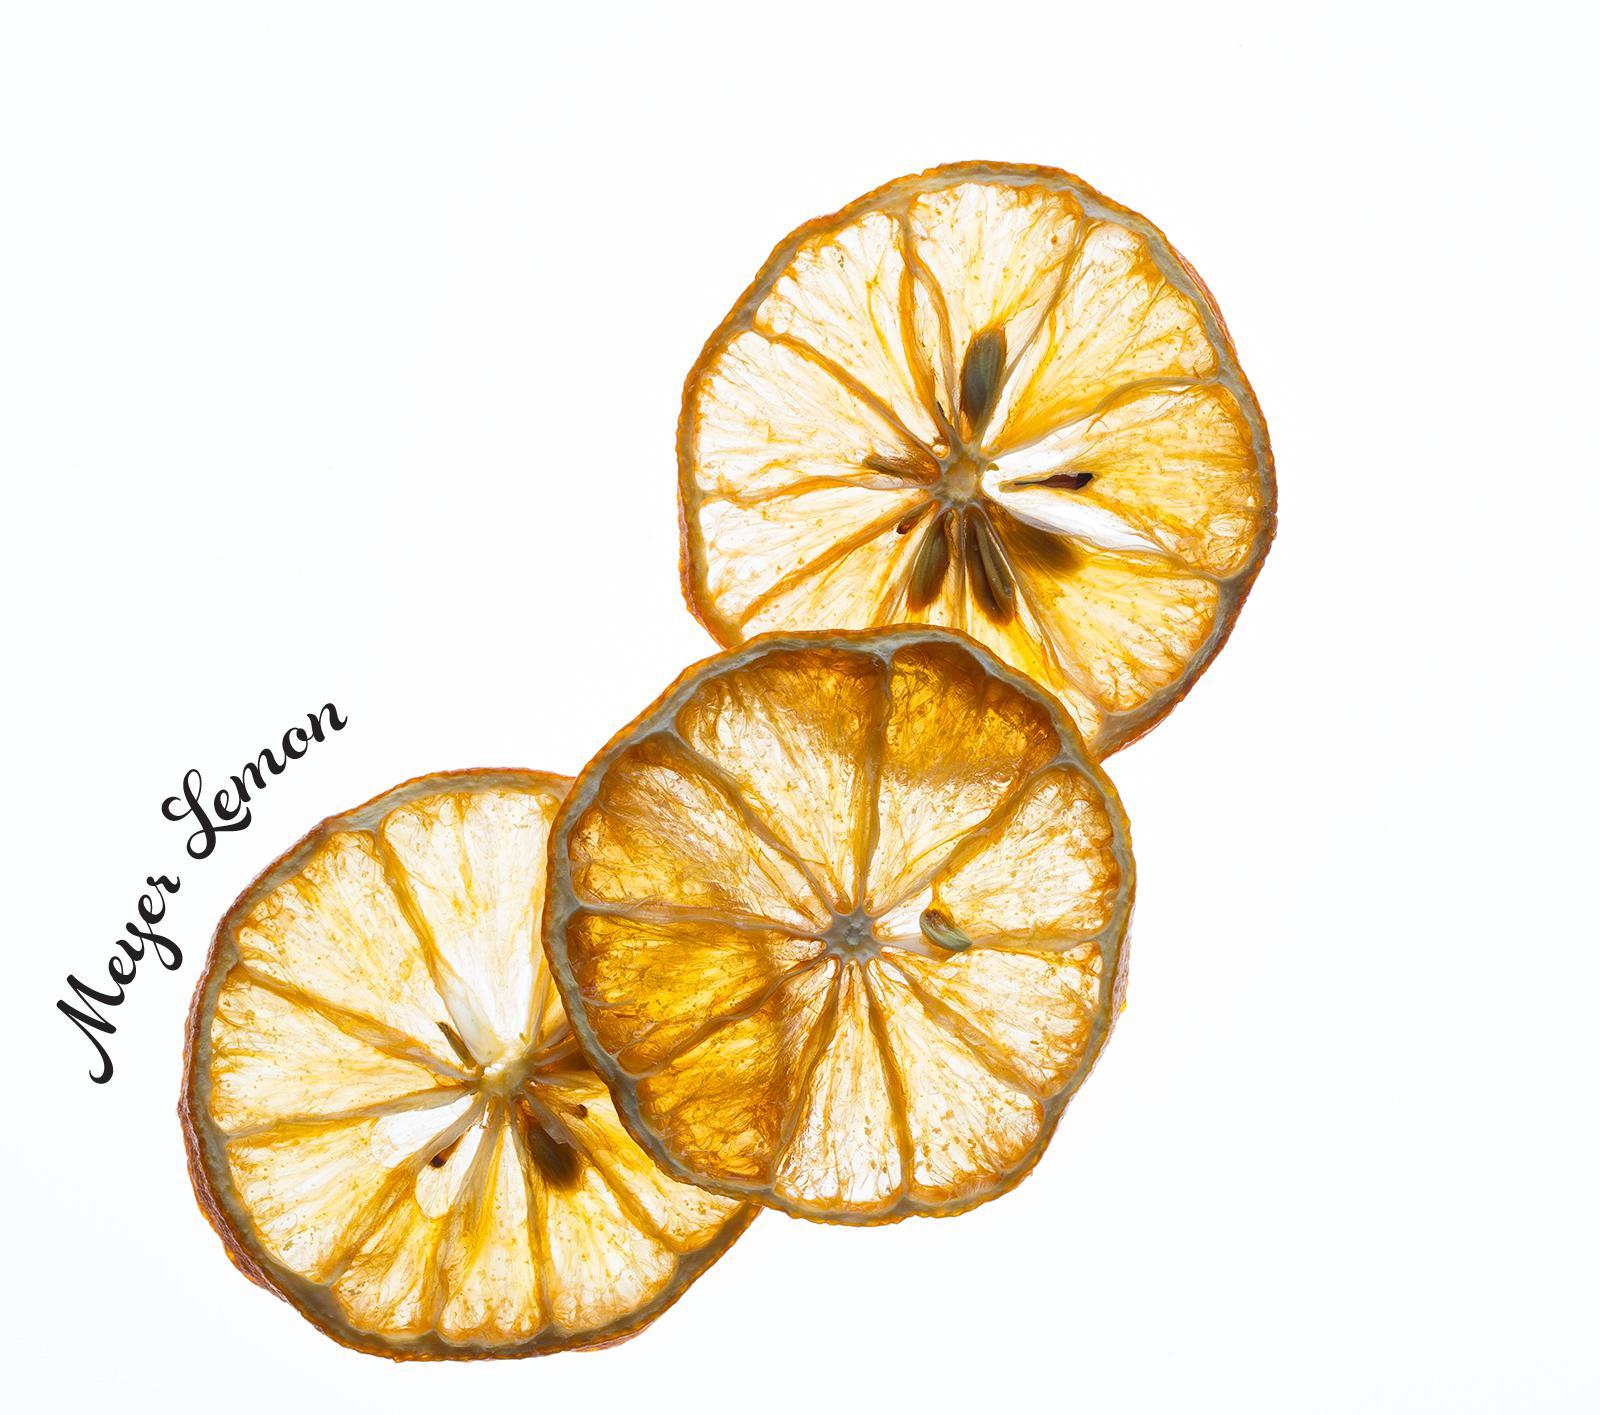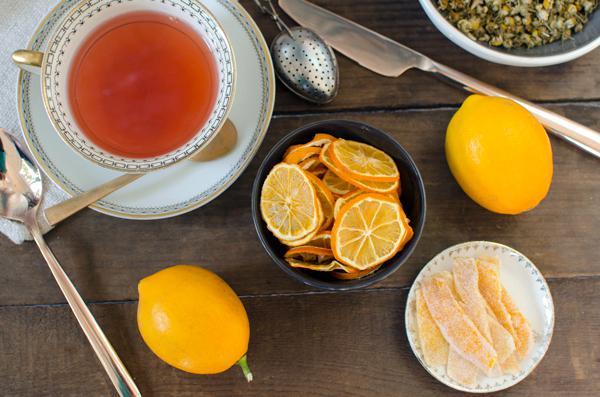The first image is the image on the left, the second image is the image on the right. Analyze the images presented: Is the assertion "Some of the lemons are not sliced." valid? Answer yes or no. Yes. The first image is the image on the left, the second image is the image on the right. Assess this claim about the two images: "There are dried sliced oranges in a back bowl on a wooden table, there is a tea cup next to the bowl". Correct or not? Answer yes or no. Yes. 